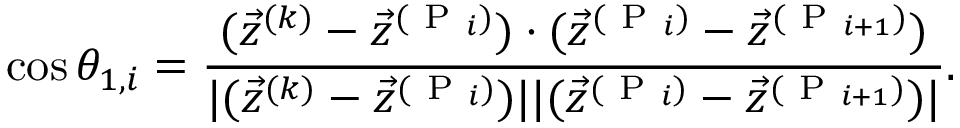<formula> <loc_0><loc_0><loc_500><loc_500>\cos \theta _ { 1 , i } = \frac { ( \vec { z } ^ { ( k ) } - \vec { z } ^ { ( P _ { i } ) } ) \cdot ( \vec { z } ^ { ( P _ { i } ) } - \vec { z } ^ { ( P _ { i + 1 } ) } ) } { | ( \vec { z } ^ { ( k ) } - \vec { z } ^ { ( P _ { i } ) } ) | | ( \vec { z } ^ { ( P _ { i } ) } - \vec { z } ^ { ( P _ { i + 1 } ) } ) | } .</formula> 